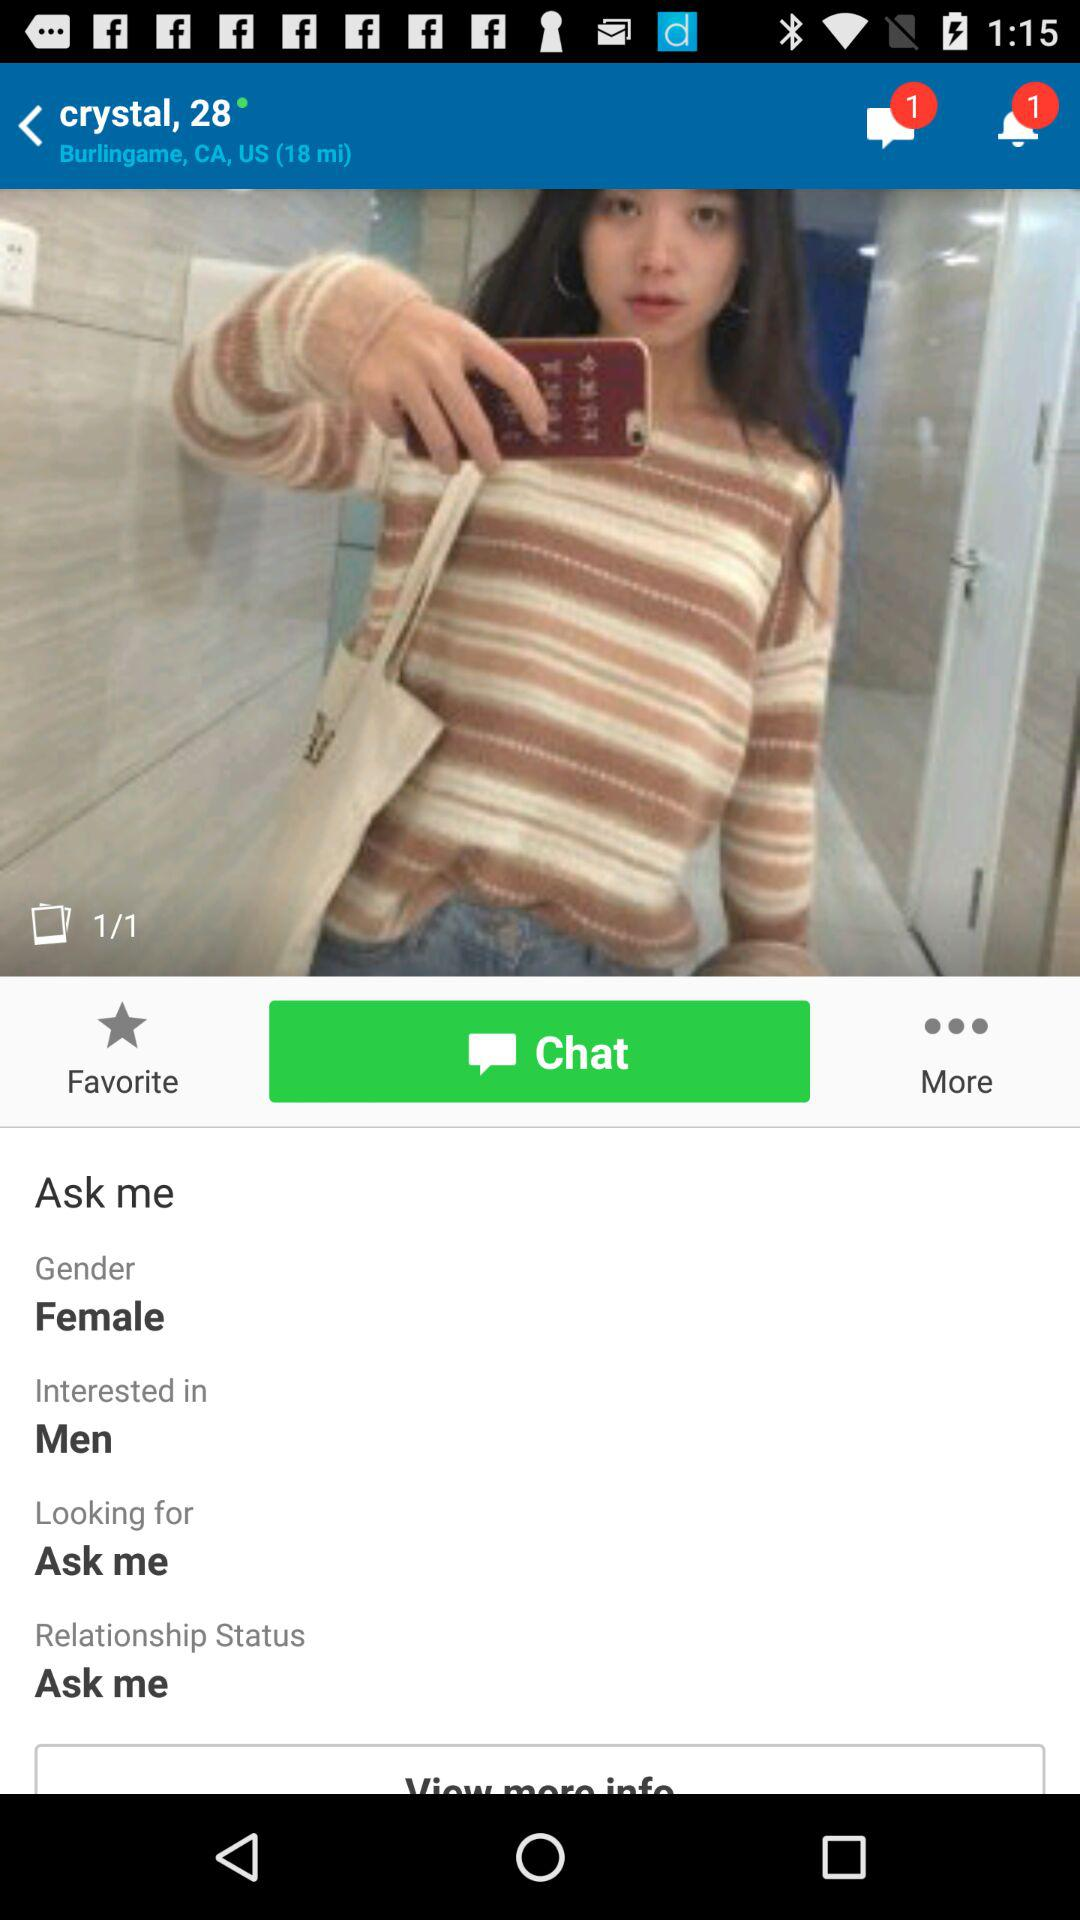What is the relationship status of the user?
Answer the question using a single word or phrase. Ask me 